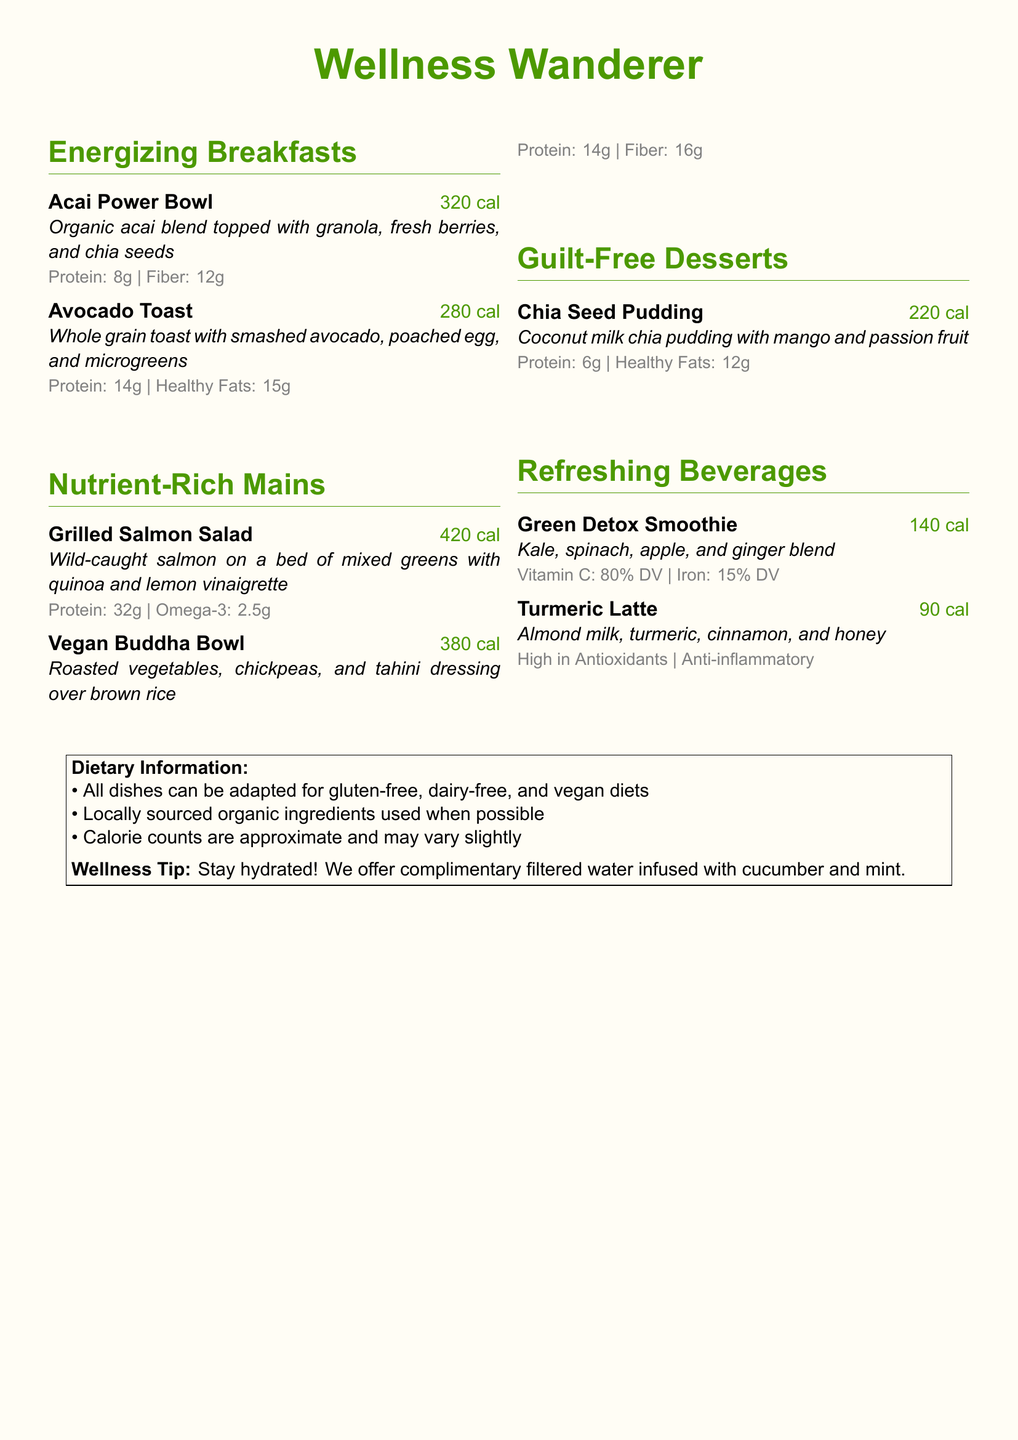What is the calorie count for the Avocado Toast? The calorie count for the Avocado Toast is listed directly in the menu item details as 280 cal.
Answer: 280 cal How much protein is in the Grilled Salmon Salad? The protein content is specified in the nutritional information section of the Grilled Salmon Salad as 32g.
Answer: 32g What is the main ingredient in the Chia Seed Pudding? The main ingredient is mentioned in the description, identifying it as coconut milk chia pudding.
Answer: Coconut milk chia pudding How many grams of fiber are in the Vegan Buddha Bowl? The fiber content is provided as 16g in the nutritional details for the Vegan Buddha Bowl.
Answer: 16g What type of milk is used in the Turmeric Latte? The type of milk is explicitly stated in the description of the Turmeric Latte as almond milk.
Answer: Almond milk What is the total calorie count for the Energizing Breakfasts section? To calculate, add the calorie counts of the two items: 320 cal + 280 cal = 600 cal.
Answer: 600 cal Which dish includes wild-caught salmon? The dish that includes wild-caught salmon is the Grilled Salmon Salad, as per the title.
Answer: Grilled Salmon Salad What wellness tip is provided in the menu? The wellness tip mentioned in the document encourages staying hydrated.
Answer: Stay hydrated How many beverages are listed in the menu? There are a total of two beverages listed in the menu: Green Detox Smoothie and Turmeric Latte.
Answer: 2 